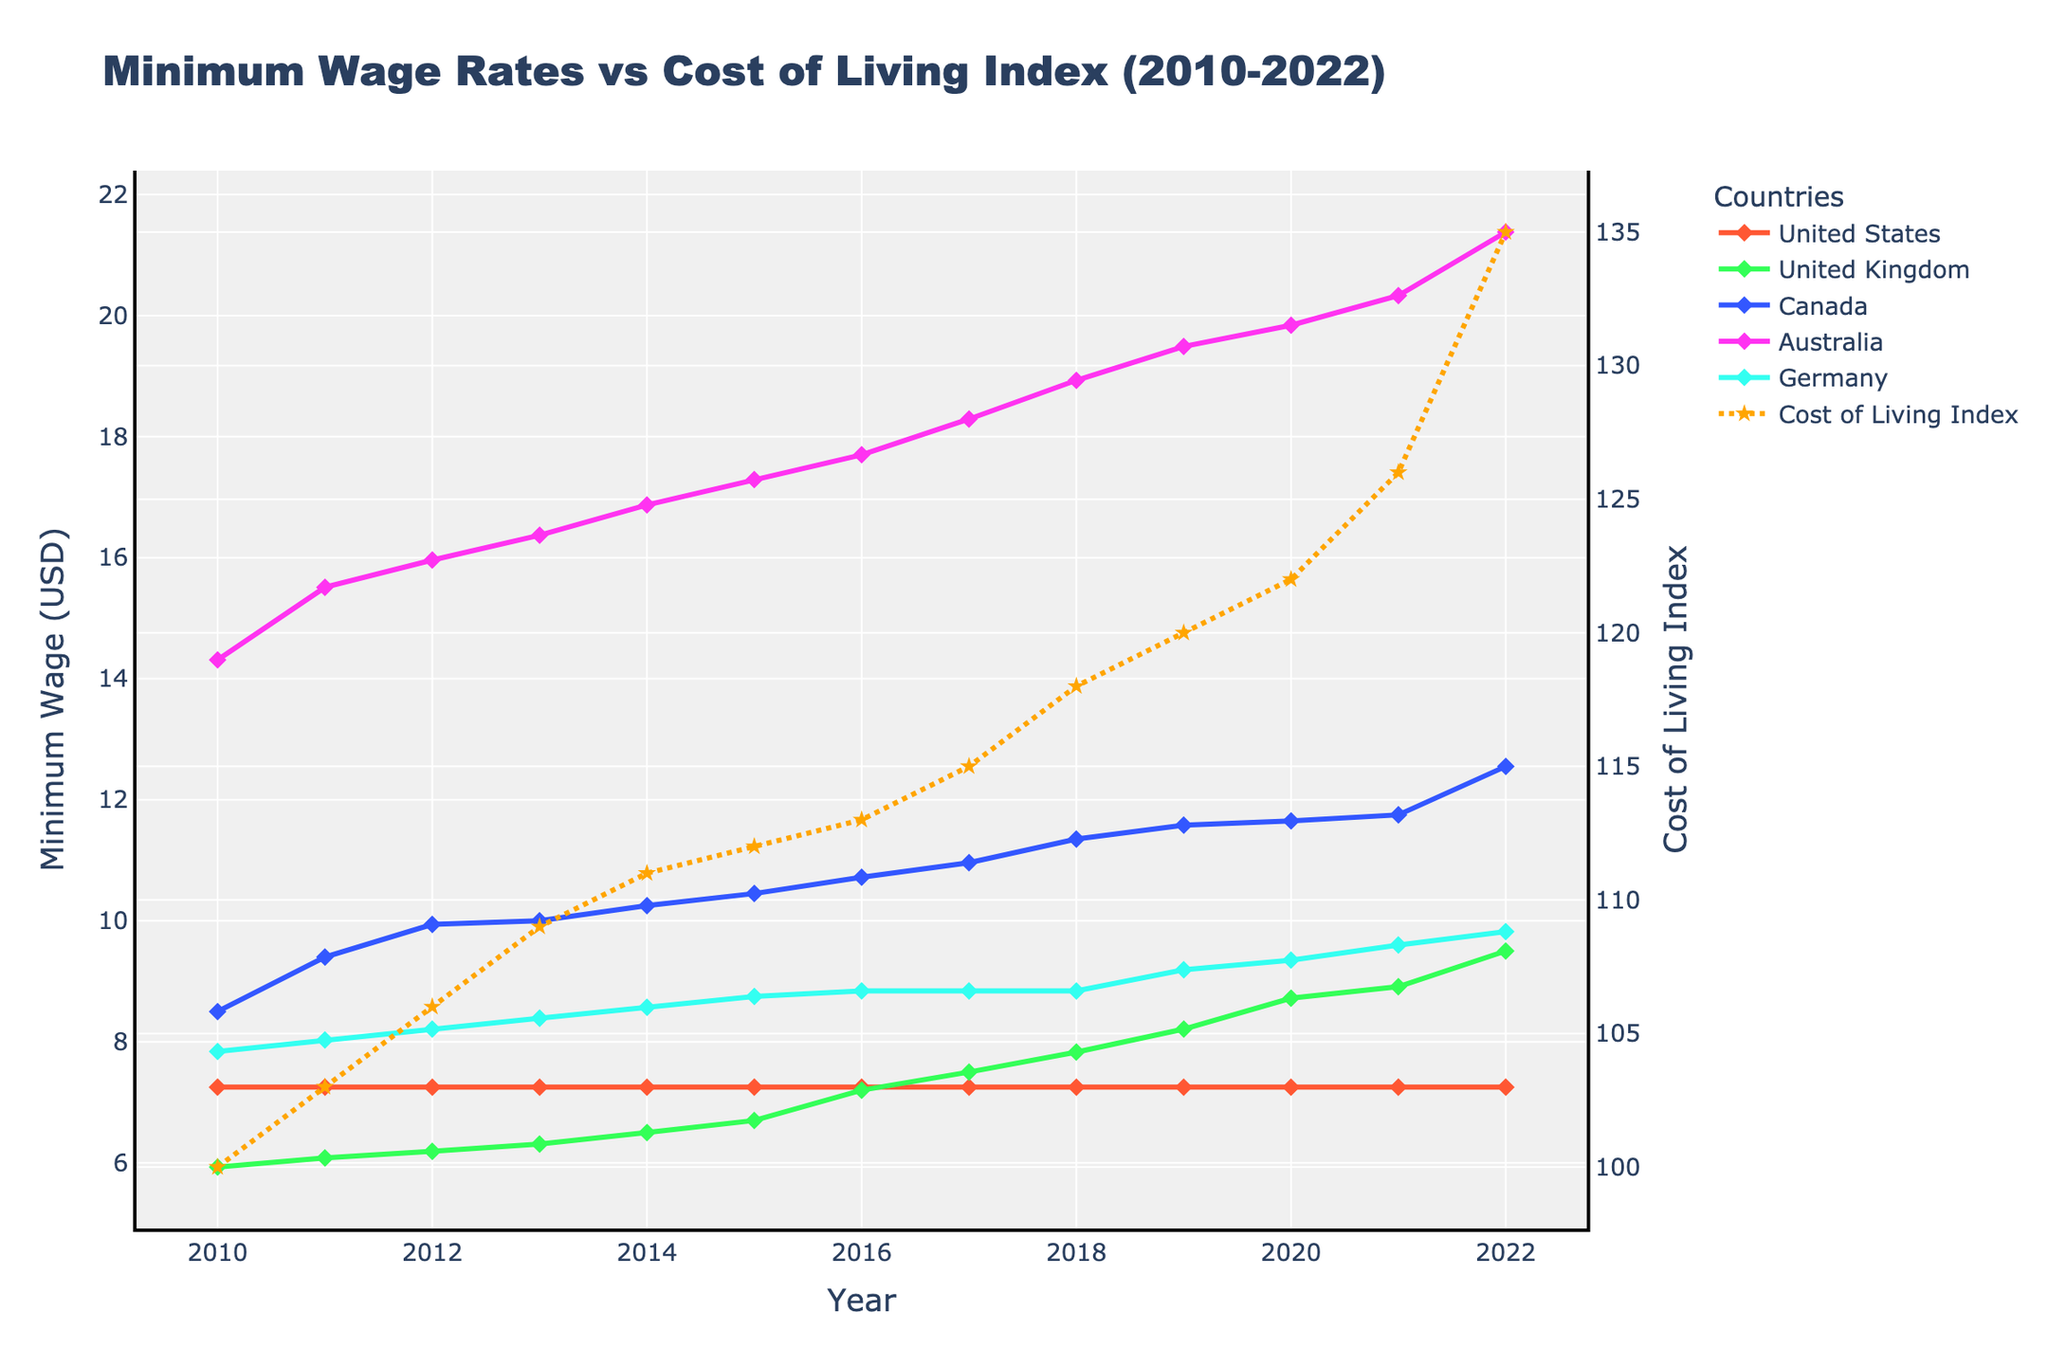Which country had the highest minimum wage in 2022? To find the highest minimum wage in 2022, look at the y-axis values for each country in 2022. Australia has the highest value of 21.38.
Answer: Australia How did the minimum wage in the United Kingdom change from 2010 to 2022? Subtract the minimum wage in 2010 (5.93) from the minimum wage in 2022 (9.50). The increase is 9.50 - 5.93 = 3.57.
Answer: Increased by 3.57 Which year had the highest Cost of Living Index? Look for the peak value on the Cost of Living Index line, which uses a dashed orange line. The highest value is 135 in 2022.
Answer: 2022 In 2020, what was the difference between the minimum wages in Canada and Germany? Find the values for Canada (11.65) and Germany (9.35) in 2020 and subtract Germany's value from Canada's value. 11.65 - 9.35 = 2.30.
Answer: 2.30 What is the average minimum wage for Australia from 2010 to 2022? Add up Australia's minimum wage values for each year and divide by the number of years. (14.31 + 15.51 + 15.96 + 16.37 + 16.87 + 17.29 + 17.70 + 18.29 + 18.93 + 19.49 + 19.84 + 20.33 + 21.38) / 13 = 17.81.
Answer: 17.81 Which country saw the least change in its minimum wage from 2010 to 2022? Compare the 2010 and 2022 values for each country. The United States shows no change, staying steady at 7.25.
Answer: United States By how much did the Cost of Living Index increase between 2010 and 2015? Subtract the 2010 Cost of Living Index (100) from the 2015 value (112). 112 - 100 = 12.
Answer: 12 What was the minimum wage trend in Canada from 2010 to 2022? Observe the year-to-year change in Canada's line. The trend is consistently upward, starting from 8.50 in 2010 and reaching 12.55 in 2022.
Answer: Increasing Which country's minimum wage in 2021 was closest to the Cost of Living Index in the same year? Compare the 2021 values: United States (7.25), United Kingdom (8.91), Canada (11.75), Australia (20.33), Germany (9.60). The Cost of Living Index is 126, and Australia, with a value of 20.33, is closest.
Answer: Australia As of 2022, which country has the smallest gap between its minimum wage and the Cost of Living Index? Determine the differences for each country in 2022: United States (7.25, difference 135-7.25=127.75), United Kingdom (9.50, 135-9.50=125.50), Canada (12.55, 135-12.55=122.45), Australia (21.38, 135-21.38=113.62), Germany (9.82, 135-9.82=125.18). Australia has the smallest gap of 113.62.
Answer: Australia 